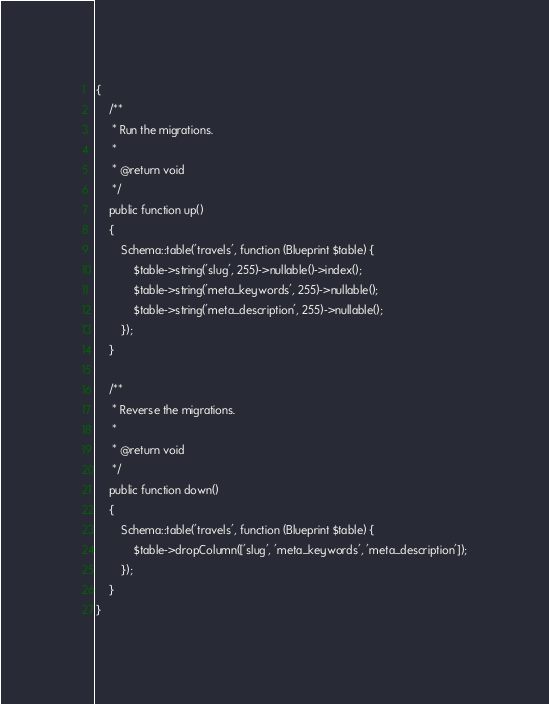<code> <loc_0><loc_0><loc_500><loc_500><_PHP_>{
    /**
     * Run the migrations.
     *
     * @return void
     */
    public function up()
    {
        Schema::table('travels', function (Blueprint $table) {
            $table->string('slug', 255)->nullable()->index();
            $table->string('meta_keywords', 255)->nullable();
            $table->string('meta_description', 255)->nullable();
        });
    }

    /**
     * Reverse the migrations.
     *
     * @return void
     */
    public function down()
    {
        Schema::table('travels', function (Blueprint $table) {
            $table->dropColumn(['slug', 'meta_keywords', 'meta_description']);
        });
    }
}
</code> 